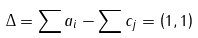Convert formula to latex. <formula><loc_0><loc_0><loc_500><loc_500>\Delta = \sum a _ { i } - \sum c _ { j } = \left ( 1 , 1 \right )</formula> 